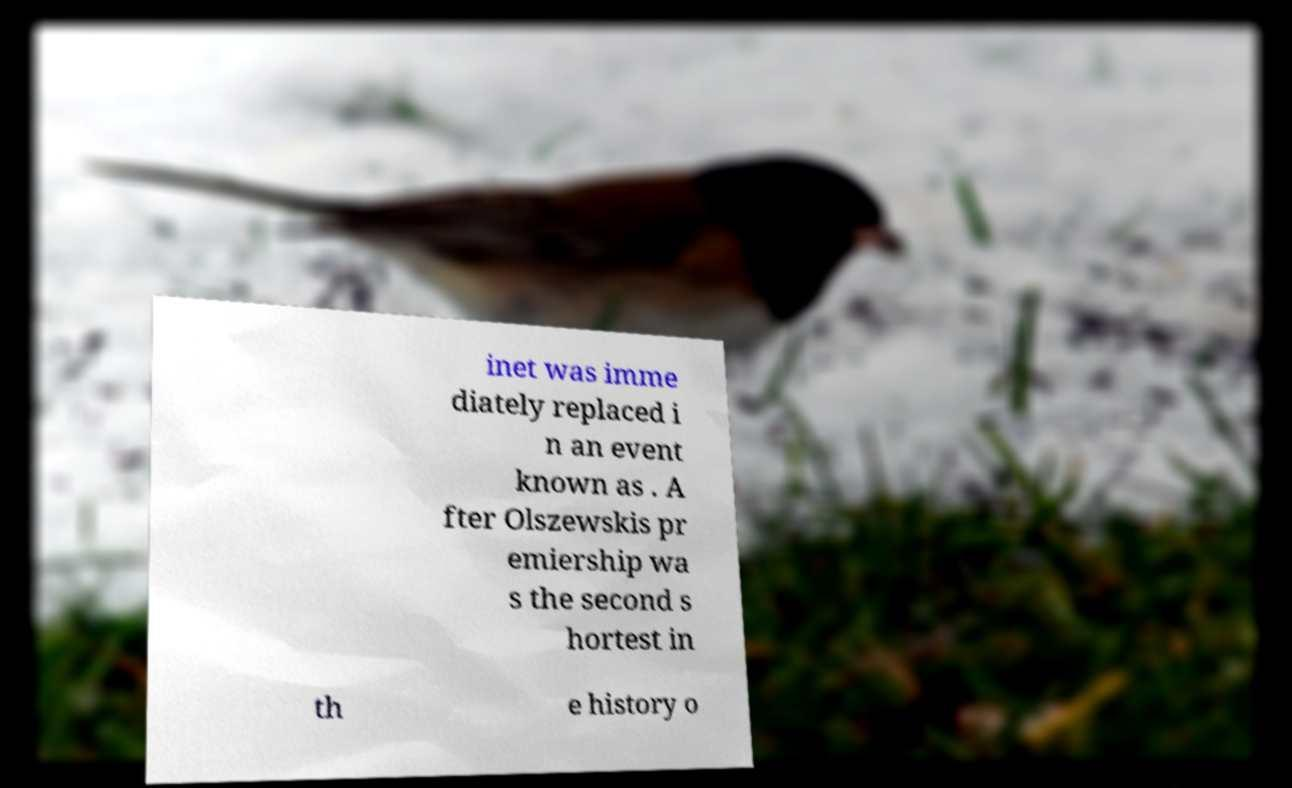Please read and relay the text visible in this image. What does it say? inet was imme diately replaced i n an event known as . A fter Olszewskis pr emiership wa s the second s hortest in th e history o 